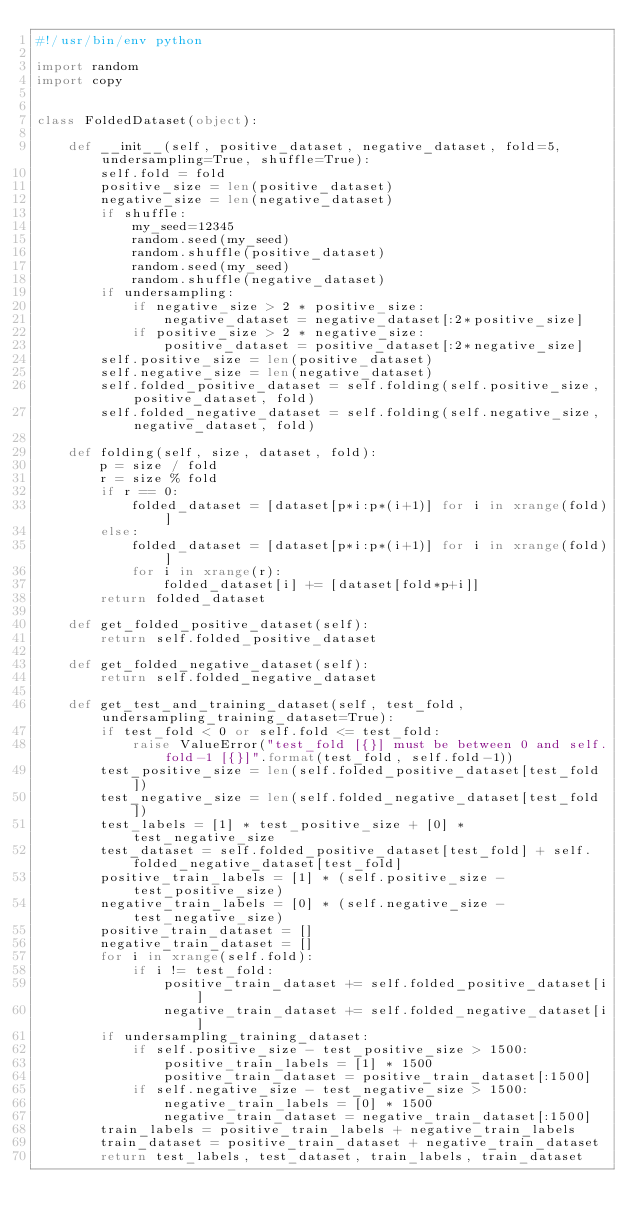Convert code to text. <code><loc_0><loc_0><loc_500><loc_500><_Python_>#!/usr/bin/env python

import random
import copy


class FoldedDataset(object):

    def __init__(self, positive_dataset, negative_dataset, fold=5, undersampling=True, shuffle=True):
        self.fold = fold
        positive_size = len(positive_dataset)
        negative_size = len(negative_dataset)
        if shuffle:
            my_seed=12345
            random.seed(my_seed)
            random.shuffle(positive_dataset)
            random.seed(my_seed)
            random.shuffle(negative_dataset)
        if undersampling:
            if negative_size > 2 * positive_size:
                negative_dataset = negative_dataset[:2*positive_size]
            if positive_size > 2 * negative_size:
                positive_dataset = positive_dataset[:2*negative_size]
        self.positive_size = len(positive_dataset)
        self.negative_size = len(negative_dataset)
        self.folded_positive_dataset = self.folding(self.positive_size, positive_dataset, fold)
        self.folded_negative_dataset = self.folding(self.negative_size, negative_dataset, fold)

    def folding(self, size, dataset, fold):
        p = size / fold
        r = size % fold
        if r == 0:
            folded_dataset = [dataset[p*i:p*(i+1)] for i in xrange(fold)]
        else:
            folded_dataset = [dataset[p*i:p*(i+1)] for i in xrange(fold)]
            for i in xrange(r):
                folded_dataset[i] += [dataset[fold*p+i]]
        return folded_dataset

    def get_folded_positive_dataset(self):
        return self.folded_positive_dataset

    def get_folded_negative_dataset(self):
        return self.folded_negative_dataset

    def get_test_and_training_dataset(self, test_fold, undersampling_training_dataset=True):
        if test_fold < 0 or self.fold <= test_fold:
            raise ValueError("test_fold [{}] must be between 0 and self.fold-1 [{}]".format(test_fold, self.fold-1))
        test_positive_size = len(self.folded_positive_dataset[test_fold])
        test_negative_size = len(self.folded_negative_dataset[test_fold])
        test_labels = [1] * test_positive_size + [0] * test_negative_size
        test_dataset = self.folded_positive_dataset[test_fold] + self.folded_negative_dataset[test_fold]
        positive_train_labels = [1] * (self.positive_size - test_positive_size)
        negative_train_labels = [0] * (self.negative_size - test_negative_size)
        positive_train_dataset = []
        negative_train_dataset = []
        for i in xrange(self.fold):
            if i != test_fold:
                positive_train_dataset += self.folded_positive_dataset[i]
                negative_train_dataset += self.folded_negative_dataset[i]
        if undersampling_training_dataset:
            if self.positive_size - test_positive_size > 1500:
                positive_train_labels = [1] * 1500
                positive_train_dataset = positive_train_dataset[:1500]
            if self.negative_size - test_negative_size > 1500:
                negative_train_labels = [0] * 1500
                negative_train_dataset = negative_train_dataset[:1500]
        train_labels = positive_train_labels + negative_train_labels
        train_dataset = positive_train_dataset + negative_train_dataset
        return test_labels, test_dataset, train_labels, train_dataset
</code> 